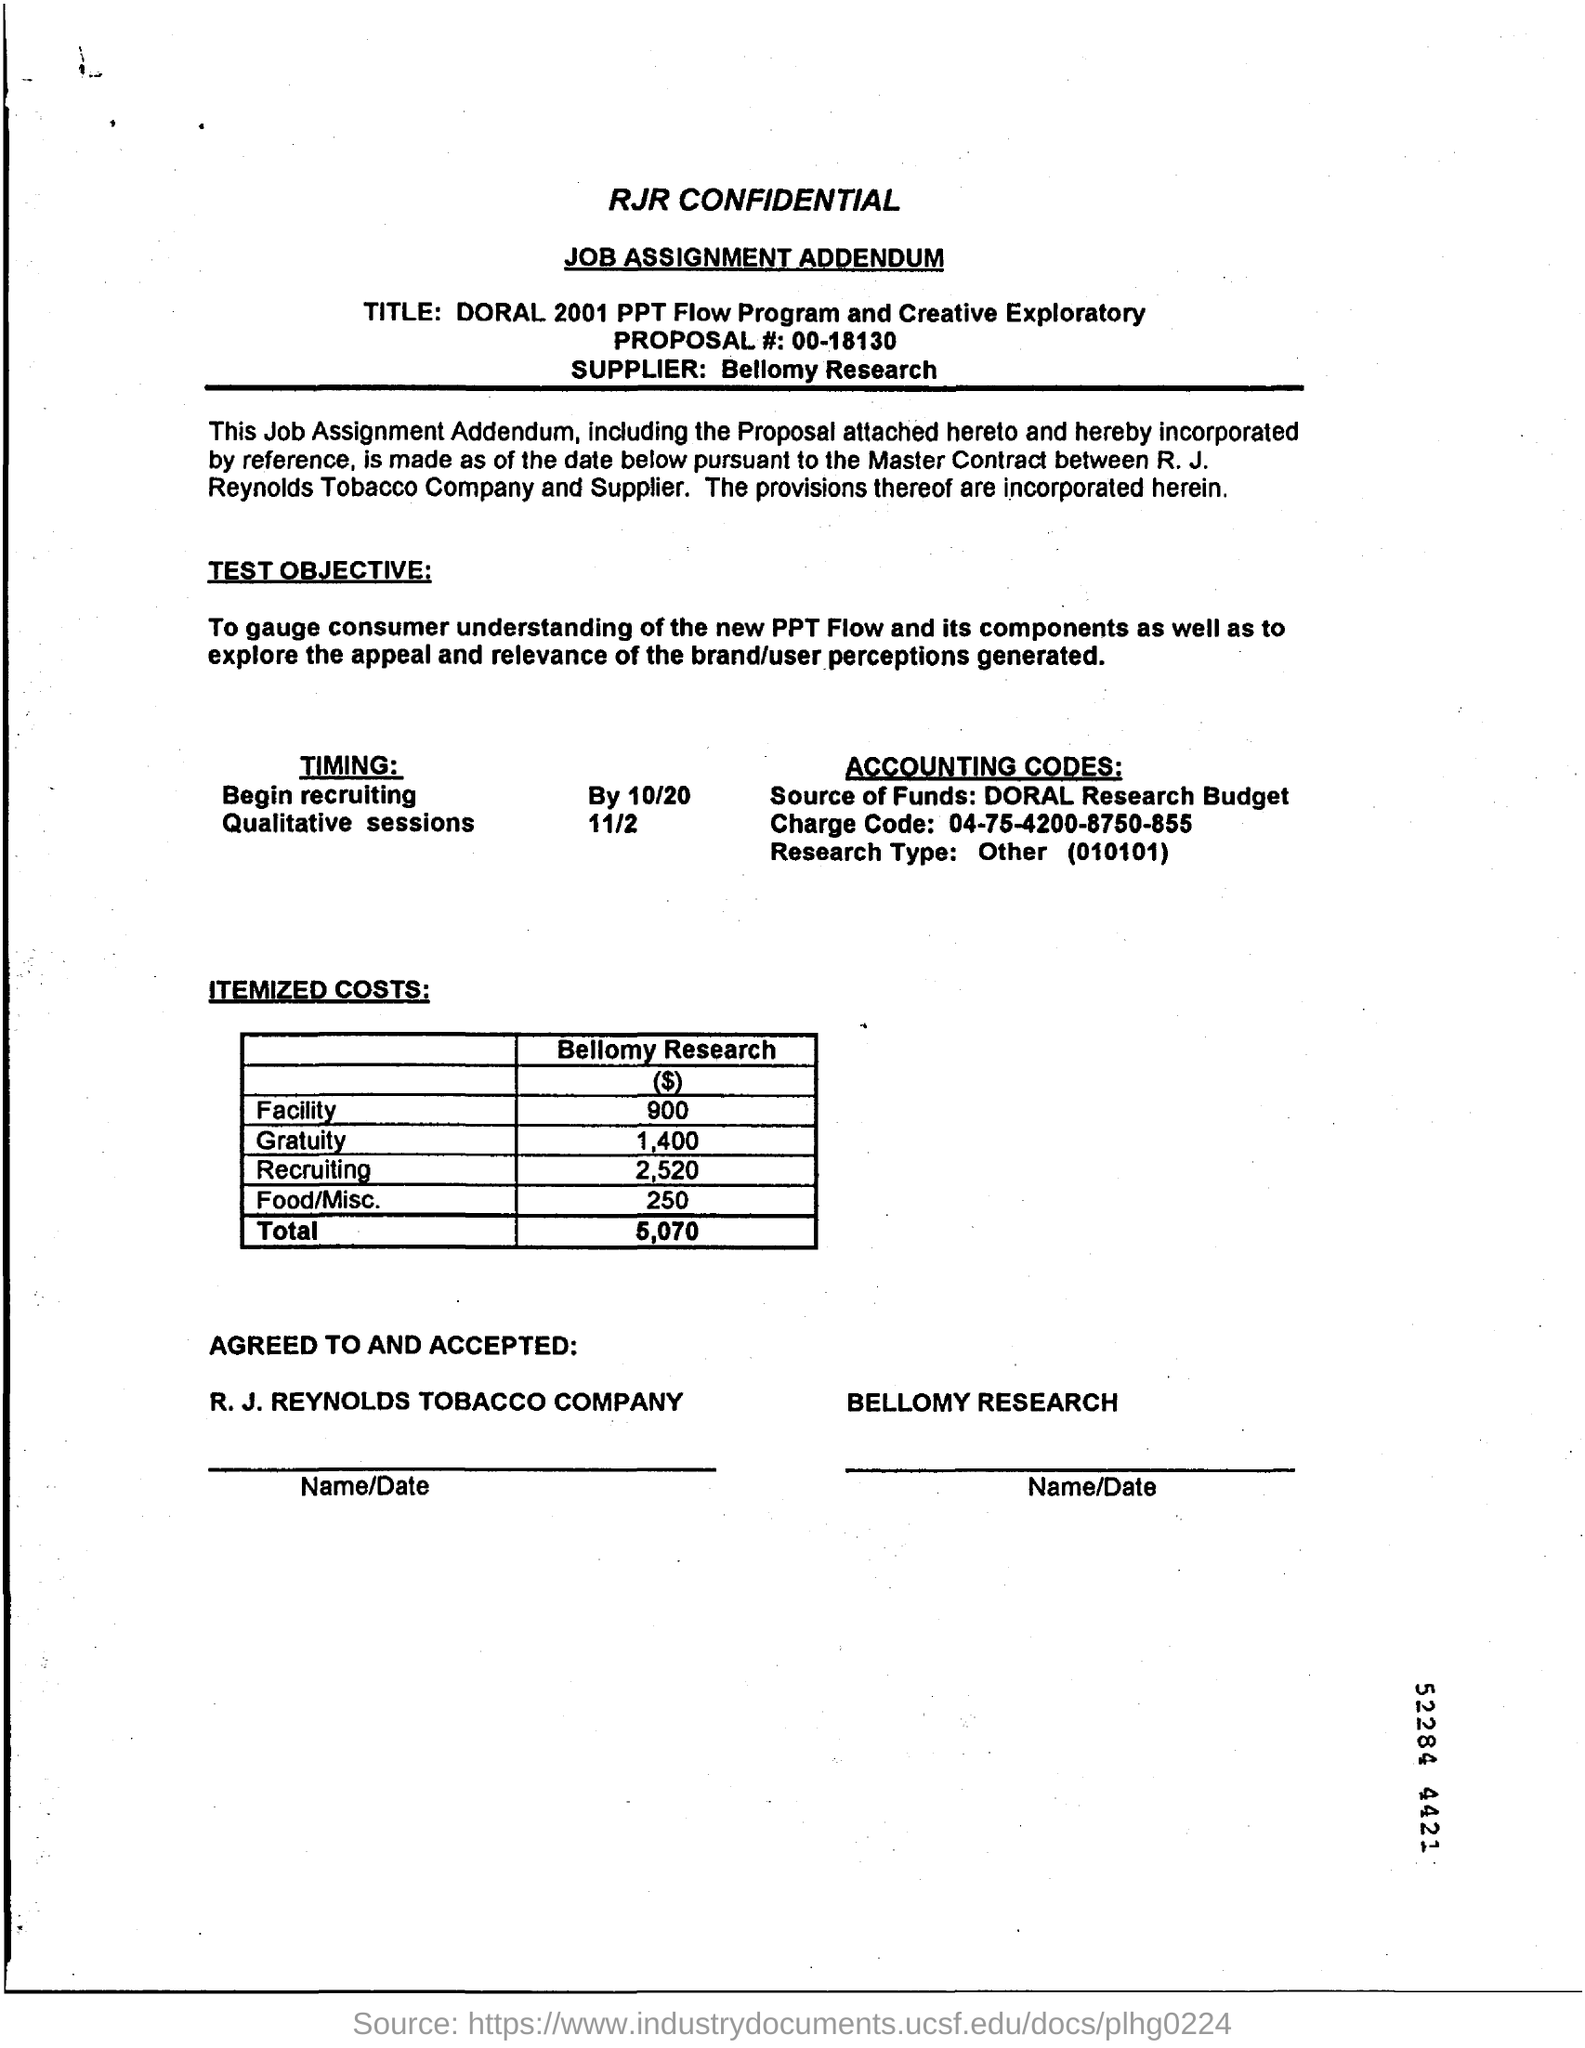Point out several critical features in this image. Bellomy Research is the supplier. The total cost of the itemized expenses is 5,070. The timing for qualitative sessions is on November 2nd. 